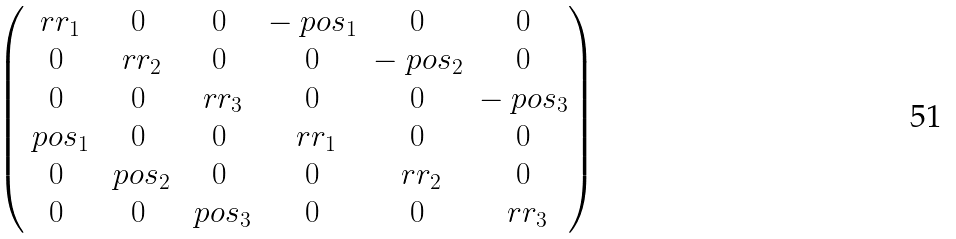Convert formula to latex. <formula><loc_0><loc_0><loc_500><loc_500>\begin{pmatrix} \ r r _ { 1 } & 0 & 0 & - \ p o s _ { 1 } & 0 & 0 \\ 0 & \ r r _ { 2 } & 0 & 0 & - \ p o s _ { 2 } & 0 \\ 0 & 0 & \ r r _ { 3 } & 0 & 0 & - \ p o s _ { 3 } \\ \ p o s _ { 1 } & 0 & 0 & \ r r _ { 1 } & 0 & 0 \\ 0 & \ p o s _ { 2 } & 0 & 0 & \ r r _ { 2 } & 0 \\ 0 & 0 & \ p o s _ { 3 } & 0 & 0 & \ r r _ { 3 } \end{pmatrix}</formula> 